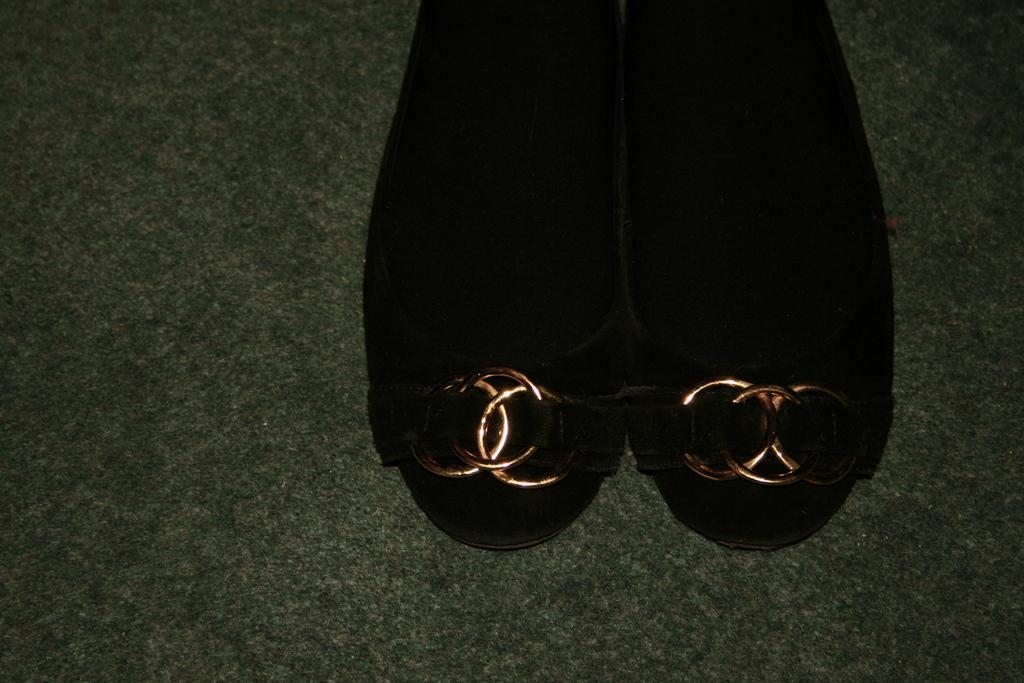Describe this image in one or two sentences. In the picture we can see a footwear which are black in color with some designs on it. 